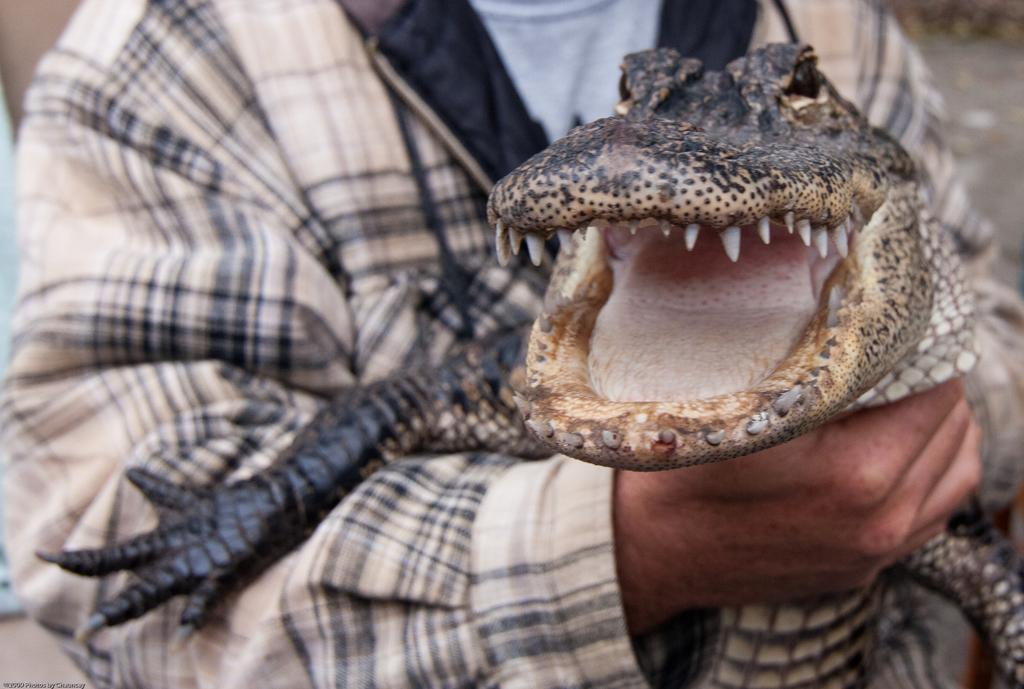What is the main subject of the image? The main subject of the image is a person. What is the person holding in their hands? The person is holding a crocodile in their hands. What direction is the person facing in the image? The provided facts do not mention the direction the person is facing. What type of army is the person associated with in the image? The provided facts do not mention any army or military affiliation. How is the person controlling the crocodile in the image? The provided facts do not mention any control or interaction between the person and the crocodile. 